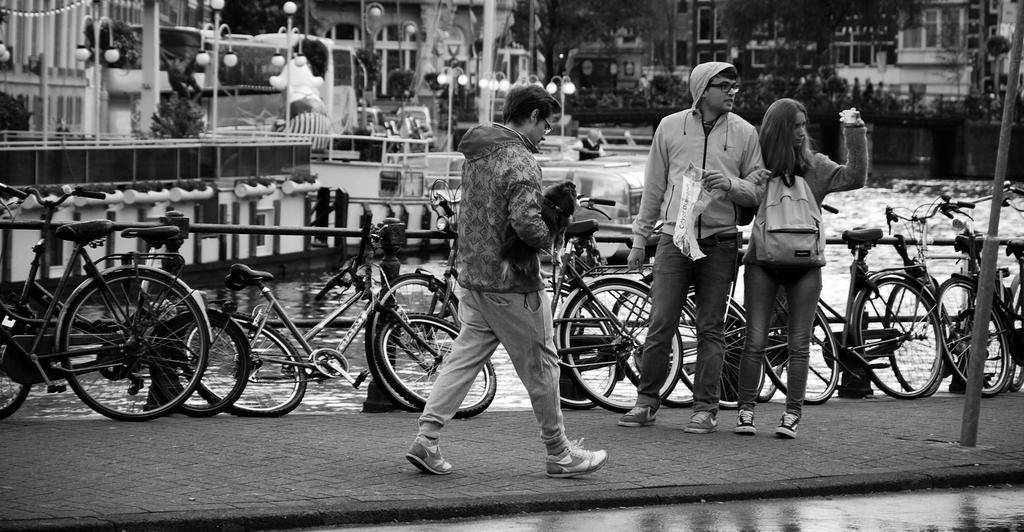Describe this image in one or two sentences. It is a black and white picture. In this picture I can see water, railings, trees, buildings, light poles, plants, bicycles, people and objects. In the front of the image one person is holding a dog and another person wore a bag. That man is holding an object.   